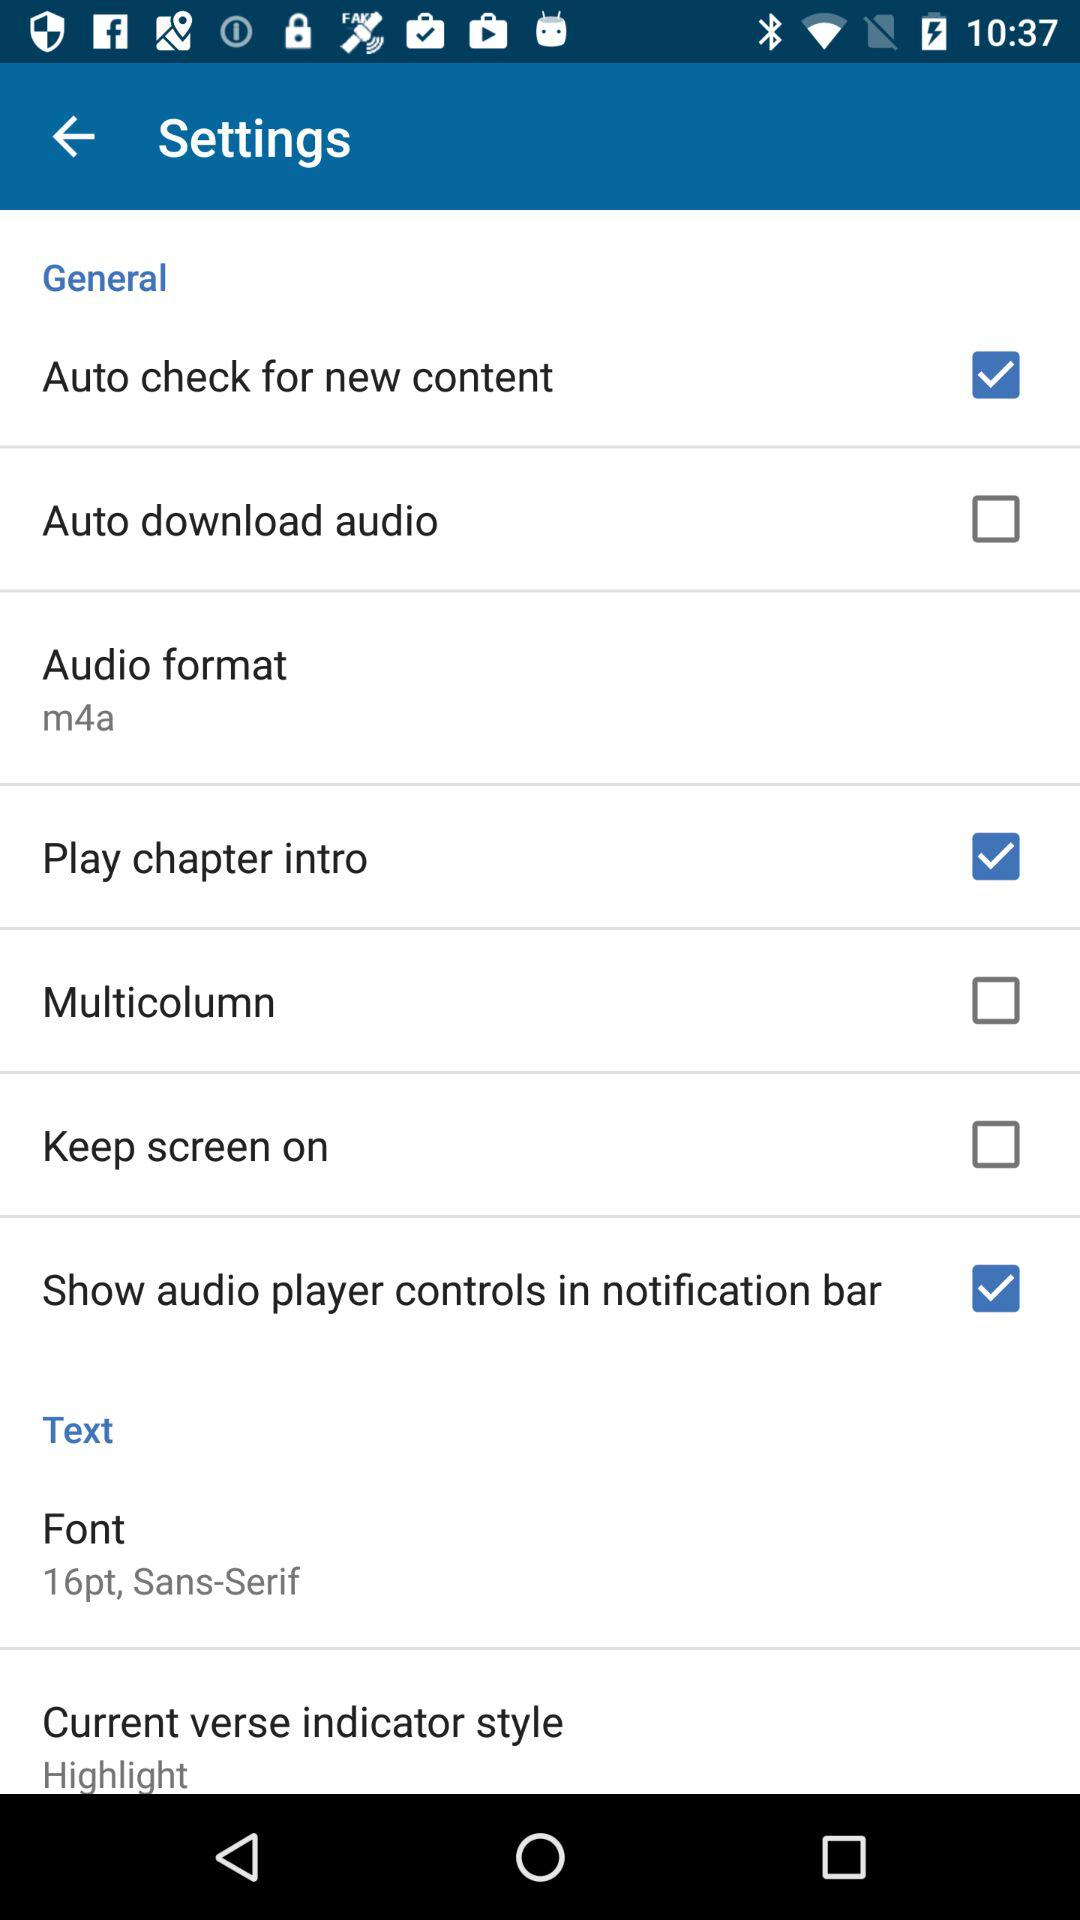What is the selected audio format? The selected audio format is "m4a". 